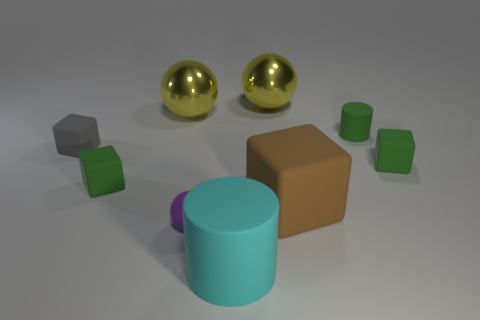Do the gray thing and the brown thing have the same shape?
Provide a short and direct response. Yes. There is a small sphere that is made of the same material as the large cyan thing; what color is it?
Provide a succinct answer. Purple. How many objects are metallic spheres behind the brown matte cube or small purple balls?
Provide a succinct answer. 3. How big is the cyan rubber cylinder to the right of the small gray thing?
Offer a very short reply. Large. There is a purple ball; does it have the same size as the gray block that is on the left side of the small purple ball?
Give a very brief answer. Yes. There is a cube behind the small object right of the small rubber cylinder; what color is it?
Keep it short and to the point. Gray. How many other objects are the same color as the big matte cylinder?
Your response must be concise. 0. What size is the purple matte sphere?
Offer a terse response. Small. Are there more small matte things to the right of the big brown matte thing than big yellow things that are right of the tiny cylinder?
Give a very brief answer. Yes. How many rubber cubes are left of the tiny green block that is on the right side of the brown object?
Ensure brevity in your answer.  3. 